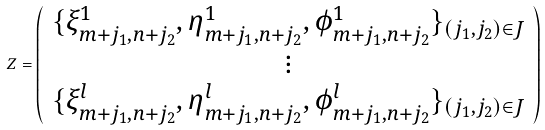<formula> <loc_0><loc_0><loc_500><loc_500>Z = \left ( \begin{array} { c } \{ \xi ^ { 1 } _ { m + j _ { 1 } , n + j _ { 2 } } , \eta ^ { 1 } _ { m + j _ { 1 } , n + j _ { 2 } } , \phi ^ { 1 } _ { m + j _ { 1 } , n + j _ { 2 } } \} _ { ( j _ { 1 } , j _ { 2 } ) \in J } \\ \vdots \\ \{ \xi ^ { l } _ { m + j _ { 1 } , n + j _ { 2 } } , \eta ^ { l } _ { m + j _ { 1 } , n + j _ { 2 } } , \phi ^ { l } _ { m + j _ { 1 } , n + j _ { 2 } } \} _ { ( j _ { 1 } , j _ { 2 } ) \in J } \end{array} \right )</formula> 